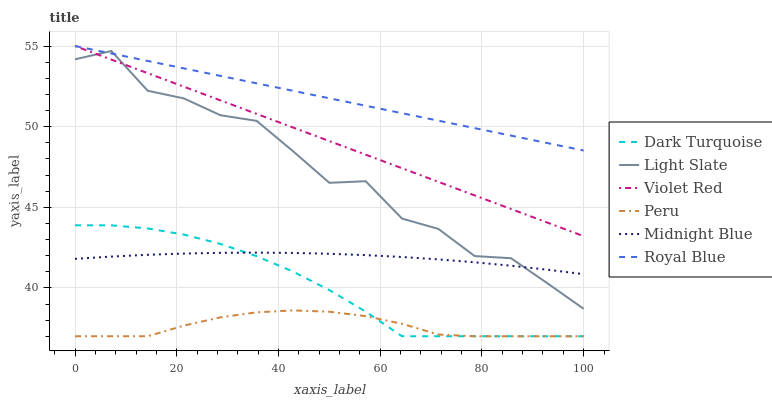Does Peru have the minimum area under the curve?
Answer yes or no. Yes. Does Royal Blue have the maximum area under the curve?
Answer yes or no. Yes. Does Midnight Blue have the minimum area under the curve?
Answer yes or no. No. Does Midnight Blue have the maximum area under the curve?
Answer yes or no. No. Is Violet Red the smoothest?
Answer yes or no. Yes. Is Light Slate the roughest?
Answer yes or no. Yes. Is Midnight Blue the smoothest?
Answer yes or no. No. Is Midnight Blue the roughest?
Answer yes or no. No. Does Dark Turquoise have the lowest value?
Answer yes or no. Yes. Does Midnight Blue have the lowest value?
Answer yes or no. No. Does Royal Blue have the highest value?
Answer yes or no. Yes. Does Midnight Blue have the highest value?
Answer yes or no. No. Is Midnight Blue less than Royal Blue?
Answer yes or no. Yes. Is Light Slate greater than Peru?
Answer yes or no. Yes. Does Peru intersect Dark Turquoise?
Answer yes or no. Yes. Is Peru less than Dark Turquoise?
Answer yes or no. No. Is Peru greater than Dark Turquoise?
Answer yes or no. No. Does Midnight Blue intersect Royal Blue?
Answer yes or no. No. 